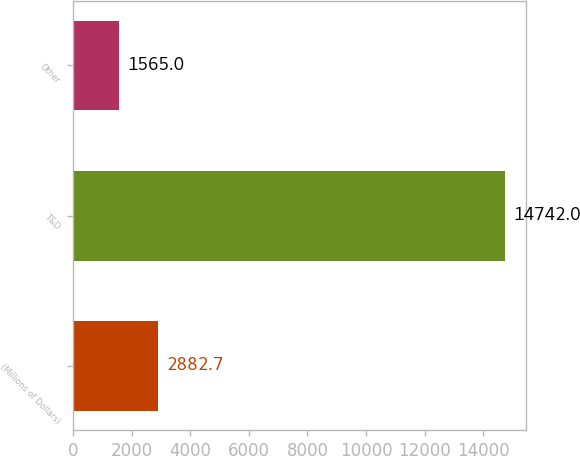Convert chart. <chart><loc_0><loc_0><loc_500><loc_500><bar_chart><fcel>(Millions of Dollars)<fcel>T&D<fcel>Other<nl><fcel>2882.7<fcel>14742<fcel>1565<nl></chart> 